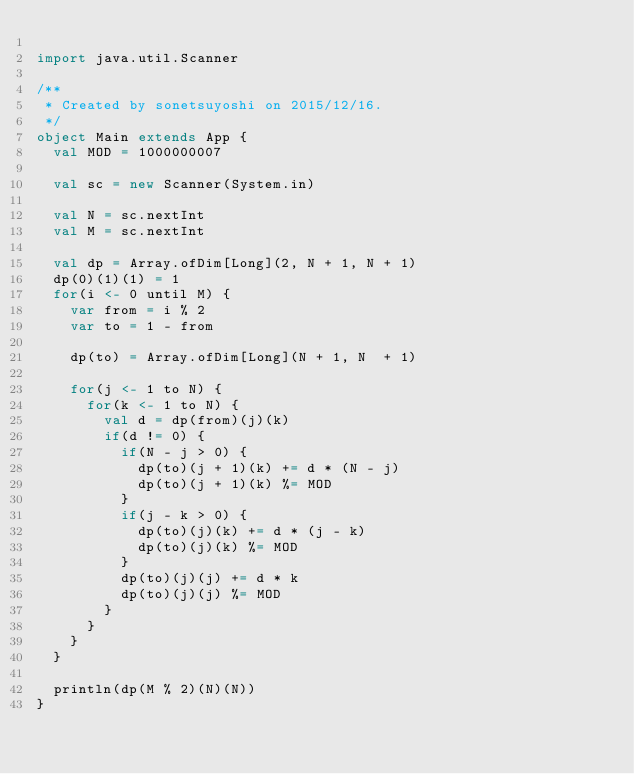<code> <loc_0><loc_0><loc_500><loc_500><_Scala_>
import java.util.Scanner

/**
 * Created by sonetsuyoshi on 2015/12/16.
 */
object Main extends App {
  val MOD = 1000000007

  val sc = new Scanner(System.in)

  val N = sc.nextInt
  val M = sc.nextInt

  val dp = Array.ofDim[Long](2, N + 1, N + 1)
  dp(0)(1)(1) = 1
  for(i <- 0 until M) {
    var from = i % 2
    var to = 1 - from

    dp(to) = Array.ofDim[Long](N + 1, N  + 1)

    for(j <- 1 to N) {
      for(k <- 1 to N) {
        val d = dp(from)(j)(k)
        if(d != 0) {
          if(N - j > 0) {
            dp(to)(j + 1)(k) += d * (N - j)
            dp(to)(j + 1)(k) %= MOD
          }
          if(j - k > 0) {
            dp(to)(j)(k) += d * (j - k)
            dp(to)(j)(k) %= MOD
          }
          dp(to)(j)(j) += d * k
          dp(to)(j)(j) %= MOD
        }
      }
    }
  }

  println(dp(M % 2)(N)(N))
}</code> 